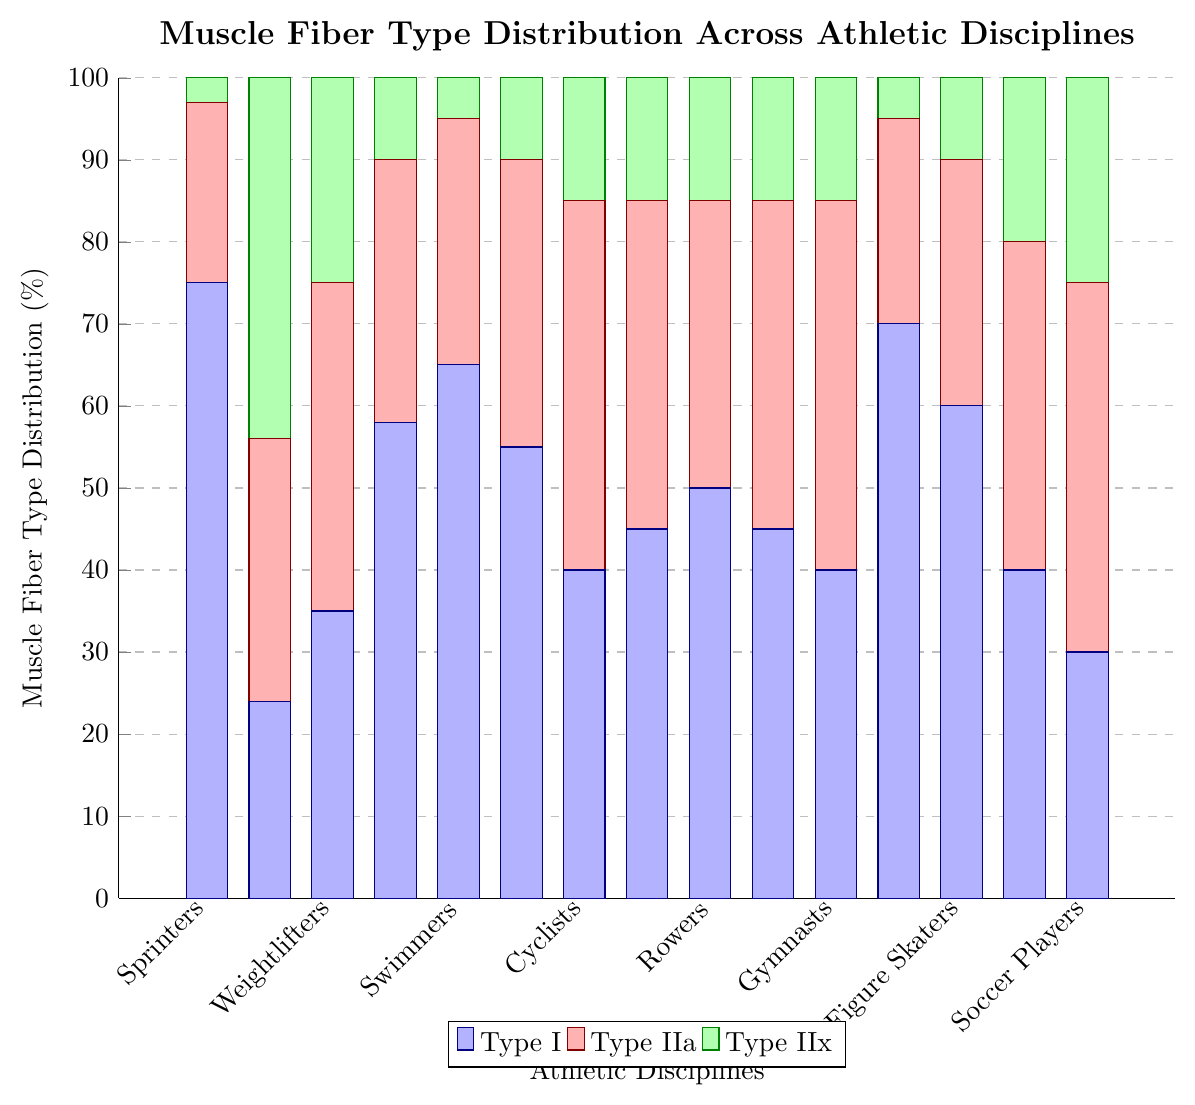Which sport has the highest percentage of Type I muscle fibers? According to the figure, Marathon Runners have the highest percentage of Type I muscle fibers at 75%.
Answer: Marathon Runners Which sport has the highest percentage of Type IIx muscle fibers? As seen in the figure, Sprinters have the highest percentage of Type IIx muscle fibers at 44%.
Answer: Sprinters What is the total percentage of Type I and Type IIa fibers for Cyclists? From the figure, the percentages of Type I and Type IIa fibers for Cyclists are 65% and 30%, respectively. Adding these two percentages gives 65 + 30 = 95%.
Answer: 95% Which sport has a more balanced distribution of Type I, Type IIa, and Type IIx muscle fibers: Weightlifters or Javelin Throwers? Weightlifters have the following distribution: Type I - 35%, Type IIa - 40%, and Type IIx - 25%. Javelin Throwers have: Type I - 30%, Type IIa - 45%, and Type IIx - 25%. Comparing the balance, Weightlifters have a more equally distributed percentage across all three types, whereas Javelin Throwers have a larger disparity.
Answer: Weightlifters What percentage of muscle fibers in Boxers are Type IIa and Type IIx combined? As per the figure, the percentages of Type IIa and Type IIx muscle fibers in Boxers are 40% and 20%, respectively. Adding these together results in 40 + 20 = 60%.
Answer: 60% How do the muscle fiber distributions of Gymnasts and Tennis Players compare for Type IIa fibers? Both Gymnasts and Tennis Players have the same percentage of Type IIa muscle fibers at 45%, as shown in the figure.
Answer: Equal Which sports have 10% or less of Type IIx muscle fibers? The sports with 10% or less Type IIx muscle fibers are Marathon Runners (3%), Swimmers (10%), Cyclists (5%), Rowers (10%), and Cross-country Skiers (5%).
Answer: Marathon Runners, Swimmers, Cyclists, Rowers, Cross-country Skiers What is the sum of all Type I muscle fiber percentages for the first three listed sports? The first three sports listed are Marathon Runners, Sprinters, and Weightlifters. Their Type I muscle fiber percentages are 75%, 24%, and 35%, respectively. Adding these gives 75 + 24 + 35 = 134%.
Answer: 134% 